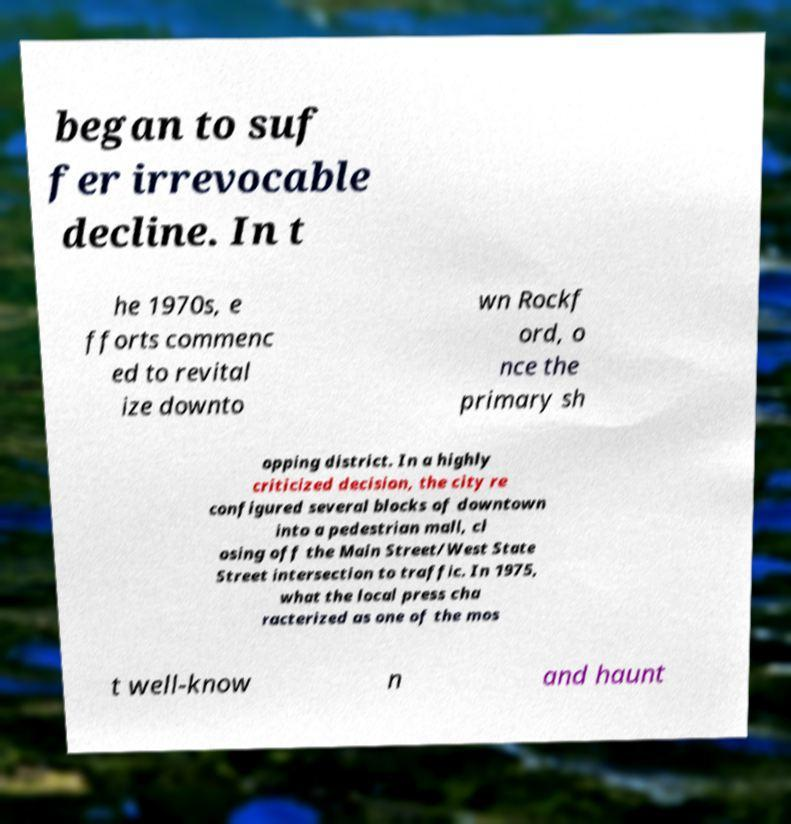Can you read and provide the text displayed in the image?This photo seems to have some interesting text. Can you extract and type it out for me? began to suf fer irrevocable decline. In t he 1970s, e fforts commenc ed to revital ize downto wn Rockf ord, o nce the primary sh opping district. In a highly criticized decision, the city re configured several blocks of downtown into a pedestrian mall, cl osing off the Main Street/West State Street intersection to traffic. In 1975, what the local press cha racterized as one of the mos t well-know n and haunt 